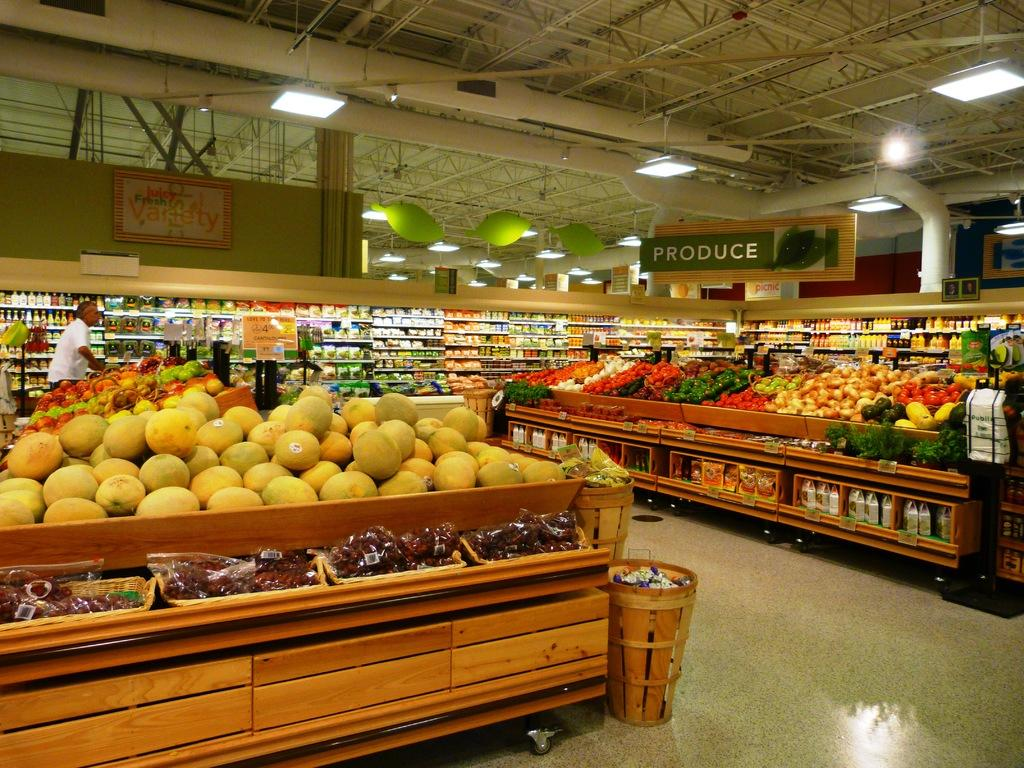<image>
Describe the image concisely. a supermarket with cantalopes and the word produce hanging over it. 